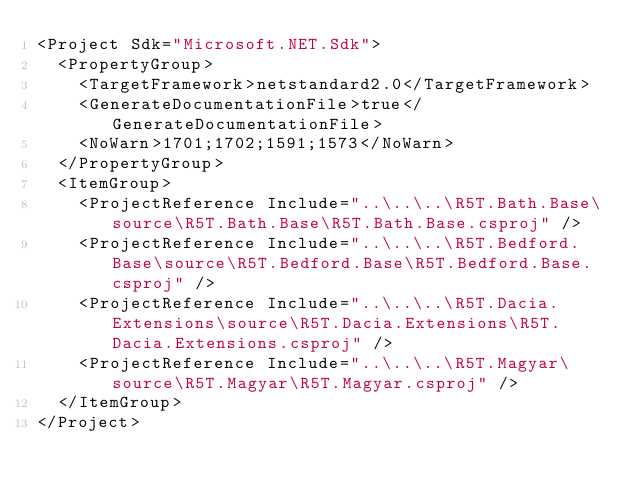<code> <loc_0><loc_0><loc_500><loc_500><_XML_><Project Sdk="Microsoft.NET.Sdk">
  <PropertyGroup>
    <TargetFramework>netstandard2.0</TargetFramework>
    <GenerateDocumentationFile>true</GenerateDocumentationFile>
    <NoWarn>1701;1702;1591;1573</NoWarn>
  </PropertyGroup>
  <ItemGroup>
    <ProjectReference Include="..\..\..\R5T.Bath.Base\source\R5T.Bath.Base\R5T.Bath.Base.csproj" />
    <ProjectReference Include="..\..\..\R5T.Bedford.Base\source\R5T.Bedford.Base\R5T.Bedford.Base.csproj" />
    <ProjectReference Include="..\..\..\R5T.Dacia.Extensions\source\R5T.Dacia.Extensions\R5T.Dacia.Extensions.csproj" />
    <ProjectReference Include="..\..\..\R5T.Magyar\source\R5T.Magyar\R5T.Magyar.csproj" />
  </ItemGroup>
</Project></code> 